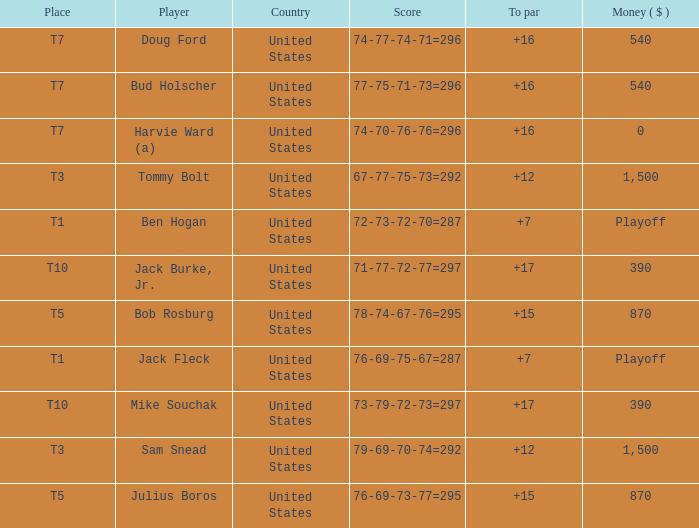What is average to par when Bud Holscher is the player? 16.0. 